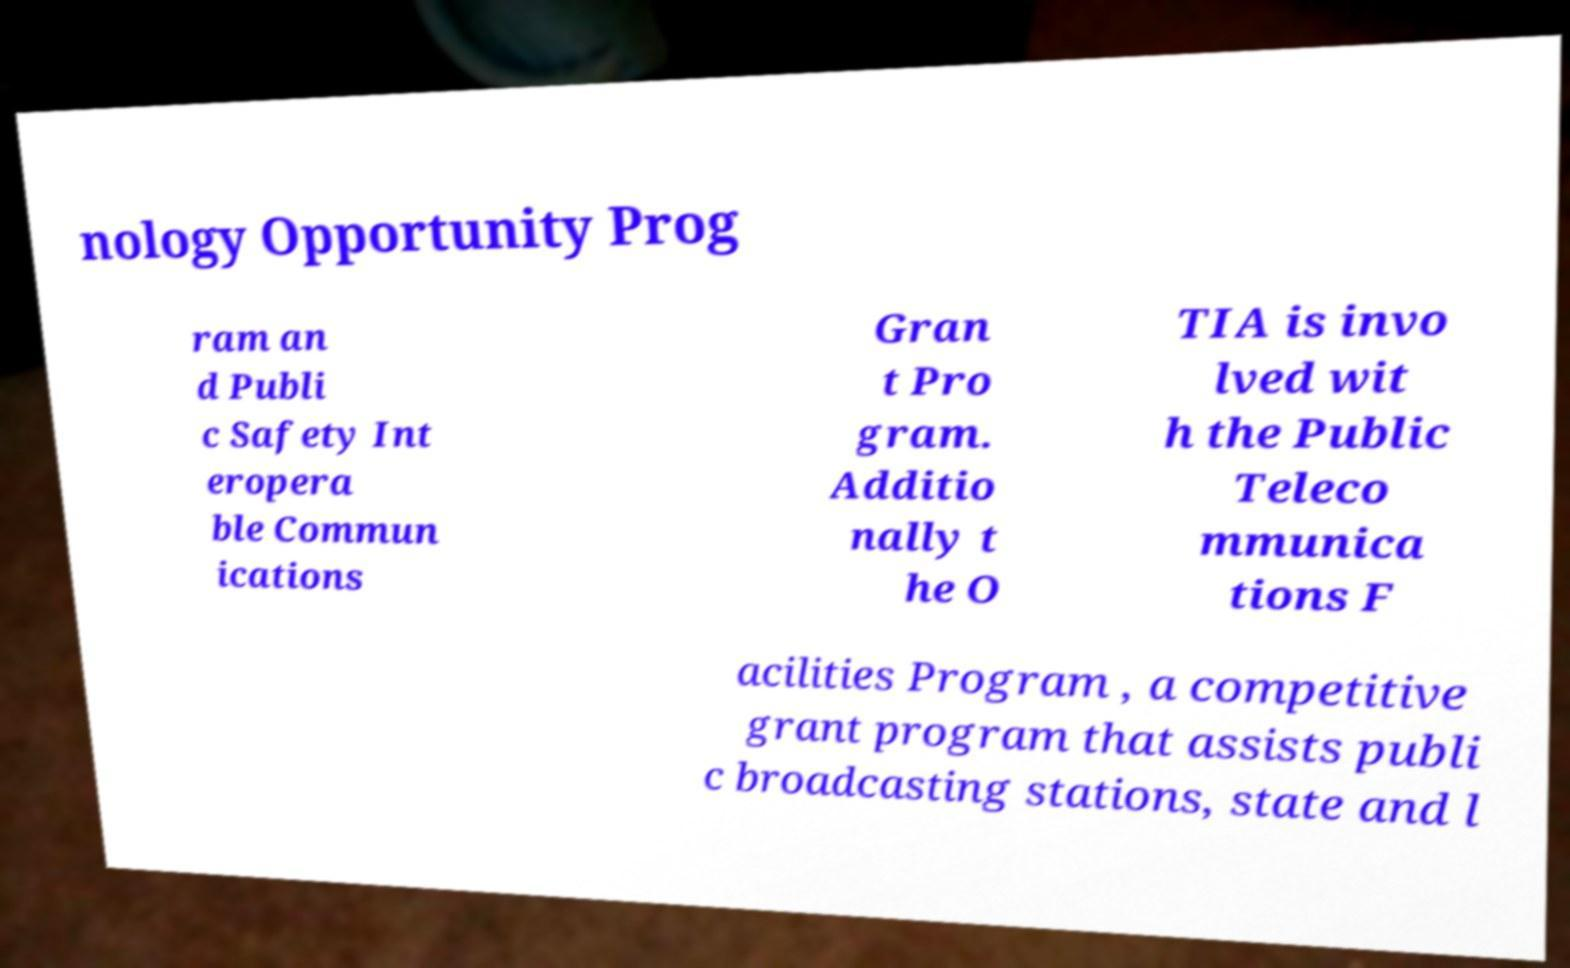Please read and relay the text visible in this image. What does it say? nology Opportunity Prog ram an d Publi c Safety Int eropera ble Commun ications Gran t Pro gram. Additio nally t he O TIA is invo lved wit h the Public Teleco mmunica tions F acilities Program , a competitive grant program that assists publi c broadcasting stations, state and l 